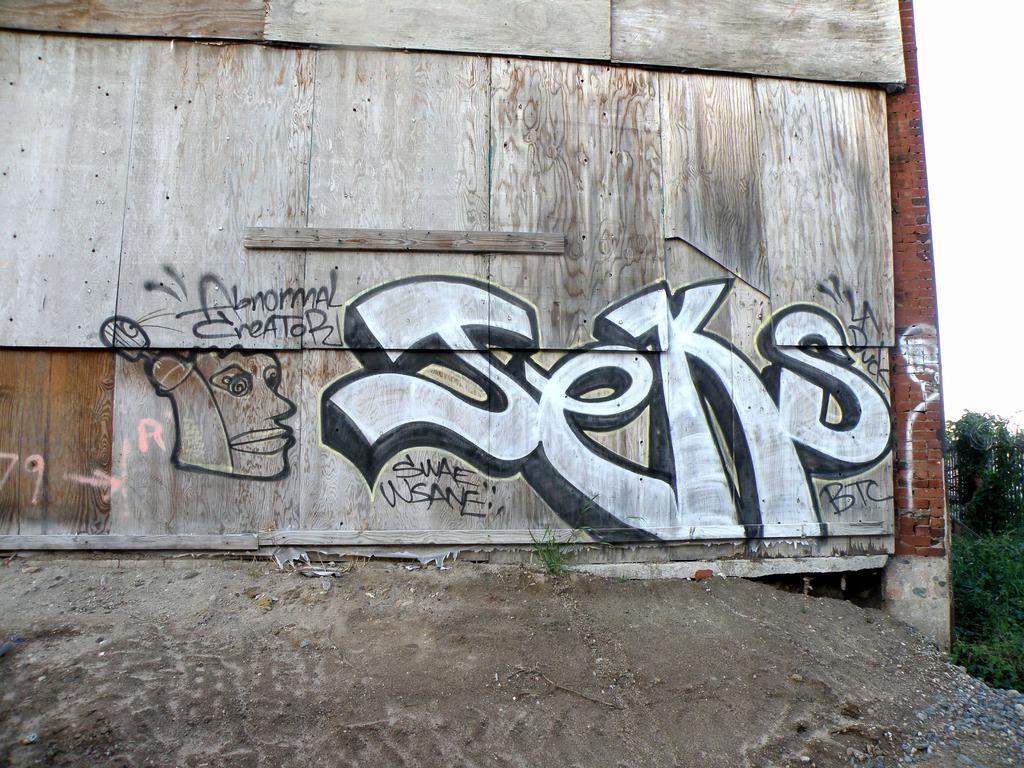Describe this image in one or two sentences. In the picture we can see graffiti on the wooden wall, on right side of the picture there are some trees, clear sky. 